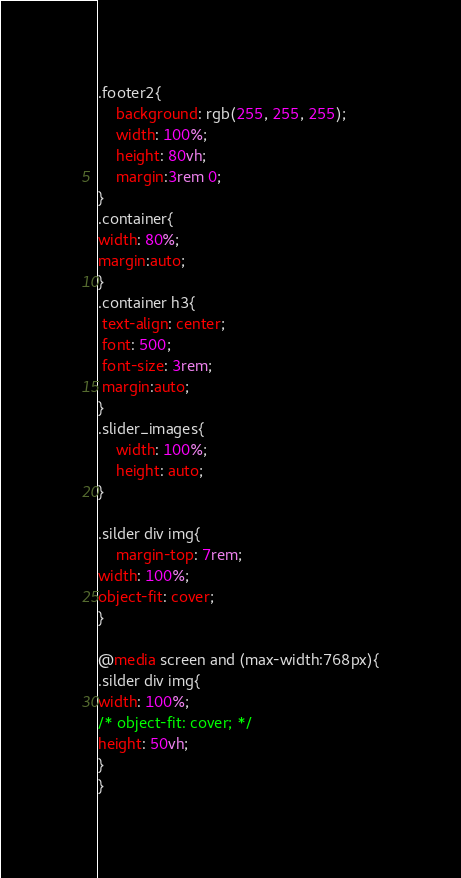Convert code to text. <code><loc_0><loc_0><loc_500><loc_500><_CSS_>.footer2{
    background: rgb(255, 255, 255);
    width: 100%;
    height: 80vh;
    margin:3rem 0;
}
.container{
width: 80%;
margin:auto;
}
.container h3{
 text-align: center;
 font: 500;
 font-size: 3rem;   
 margin:auto;
}
.slider_images{
    width: 100%;
    height: auto;
}

.silder div img{
    margin-top: 7rem;
width: 100%;
object-fit: cover;
}

@media screen and (max-width:768px){
.silder div img{
width: 100%;
/* object-fit: cover; */
height: 50vh;
}
}</code> 